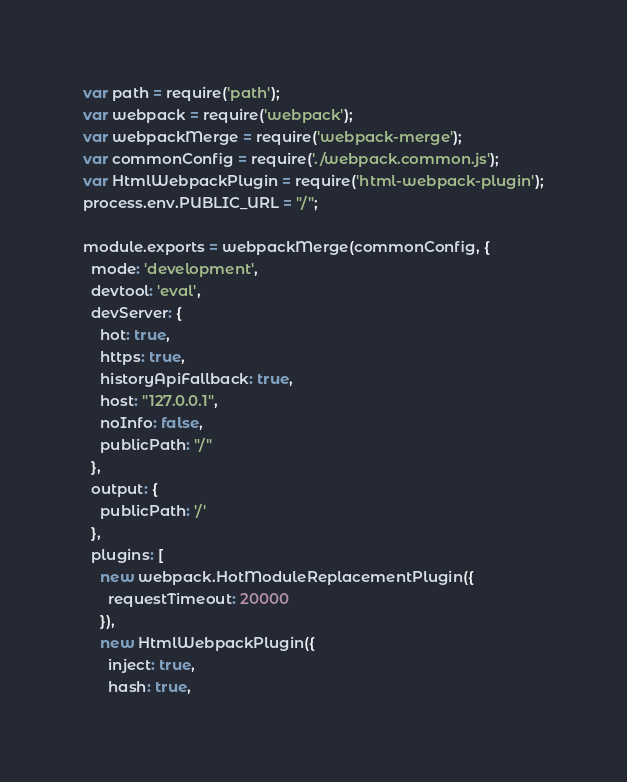Convert code to text. <code><loc_0><loc_0><loc_500><loc_500><_JavaScript_>var path = require('path');
var webpack = require('webpack');
var webpackMerge = require('webpack-merge');
var commonConfig = require('./webpack.common.js');
var HtmlWebpackPlugin = require('html-webpack-plugin');
process.env.PUBLIC_URL = "/";

module.exports = webpackMerge(commonConfig, {
  mode: 'development',
  devtool: 'eval',
  devServer: {
    hot: true,
    https: true,
    historyApiFallback: true,
    host: "127.0.0.1",
    noInfo: false,
    publicPath: "/"
  },
  output: {
    publicPath: '/'
  },
  plugins: [
    new webpack.HotModuleReplacementPlugin({
      requestTimeout: 20000
    }),
    new HtmlWebpackPlugin({
      inject: true,
      hash: true,</code> 